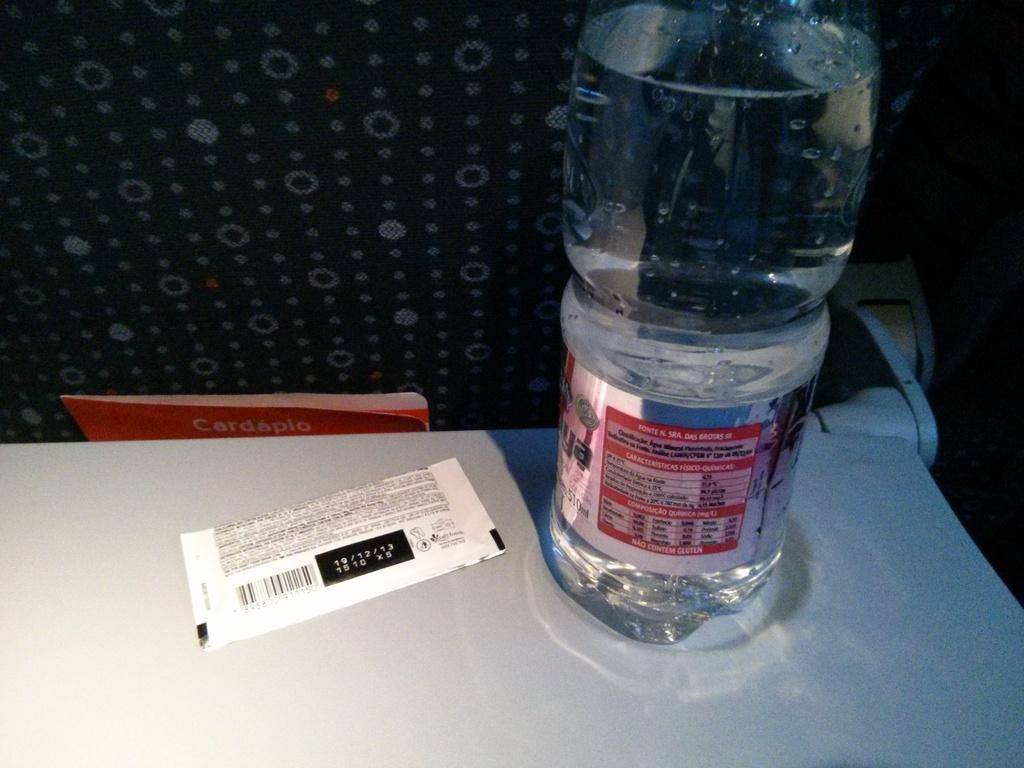<image>
Summarize the visual content of the image. A food product with a 19/12/13 expiration date is lying next to a bottle of water. 